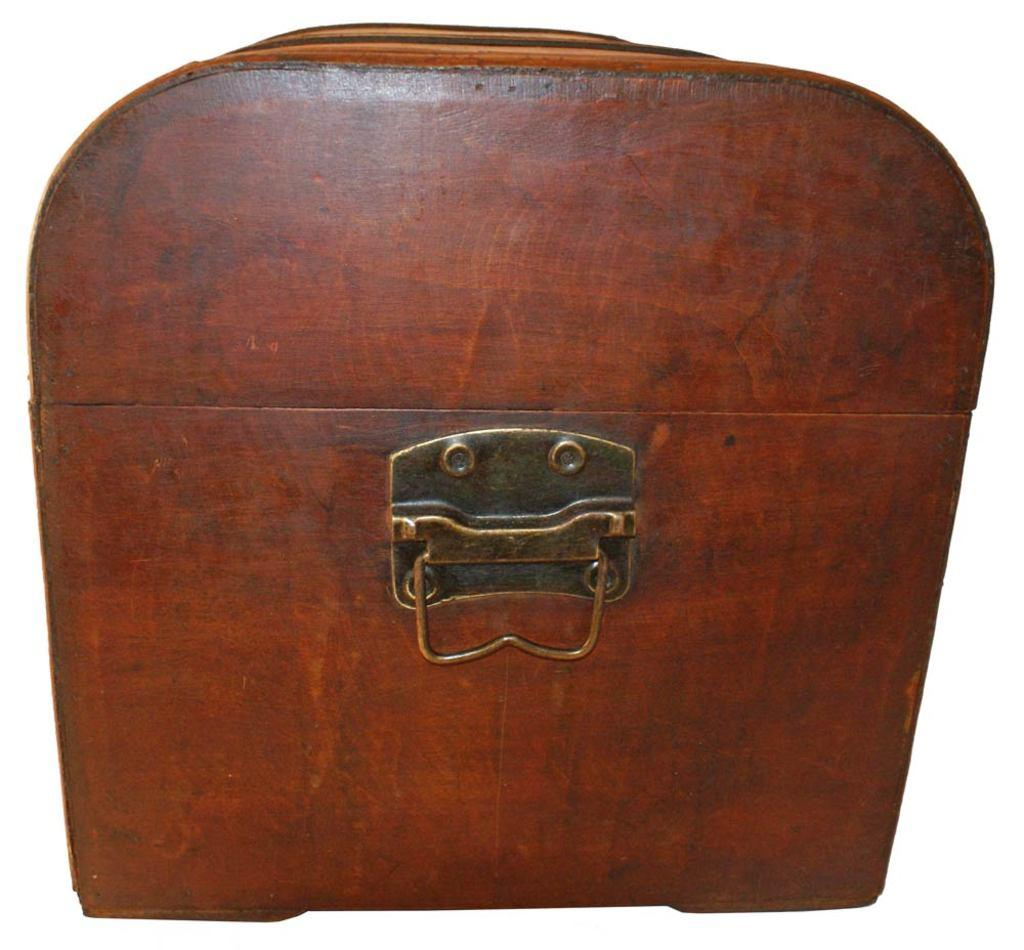What type of object is the main subject in the image? There is a wooden box in the image. What type of whip is used to care for the wooden box in the image? There is no whip or any indication of care for the wooden box in the image; it is simply a wooden box. How many brothers are present in the image? There are no people or siblings mentioned in the image, only a wooden box. 